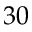Convert formula to latex. <formula><loc_0><loc_0><loc_500><loc_500>3 0</formula> 